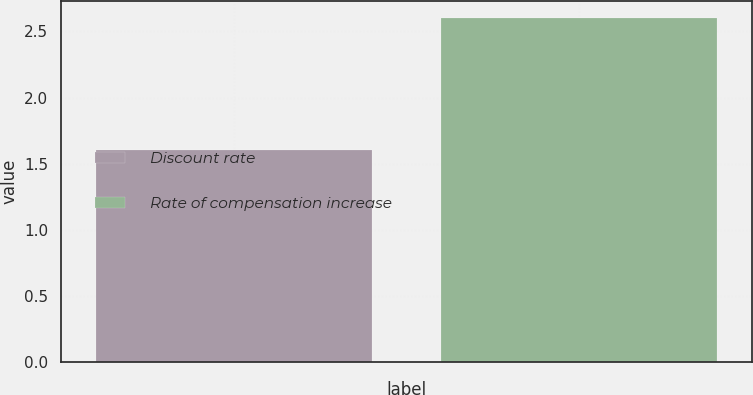<chart> <loc_0><loc_0><loc_500><loc_500><bar_chart><fcel>Discount rate<fcel>Rate of compensation increase<nl><fcel>1.6<fcel>2.6<nl></chart> 